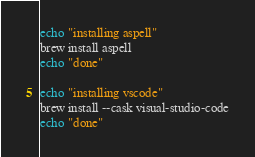Convert code to text. <code><loc_0><loc_0><loc_500><loc_500><_Bash_>echo "installing aspell"
brew install aspell
echo "done"

echo "installing vscode"
brew install --cask visual-studio-code
echo "done"</code> 